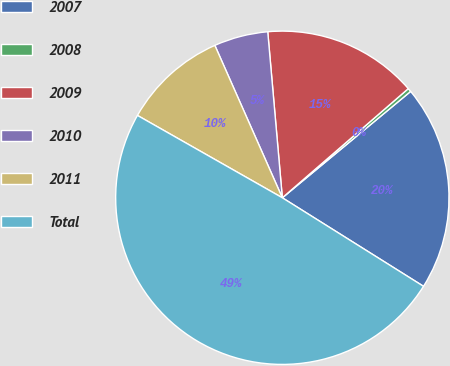<chart> <loc_0><loc_0><loc_500><loc_500><pie_chart><fcel>2007<fcel>2008<fcel>2009<fcel>2010<fcel>2011<fcel>Total<nl><fcel>19.93%<fcel>0.35%<fcel>15.03%<fcel>5.24%<fcel>10.14%<fcel>49.31%<nl></chart> 